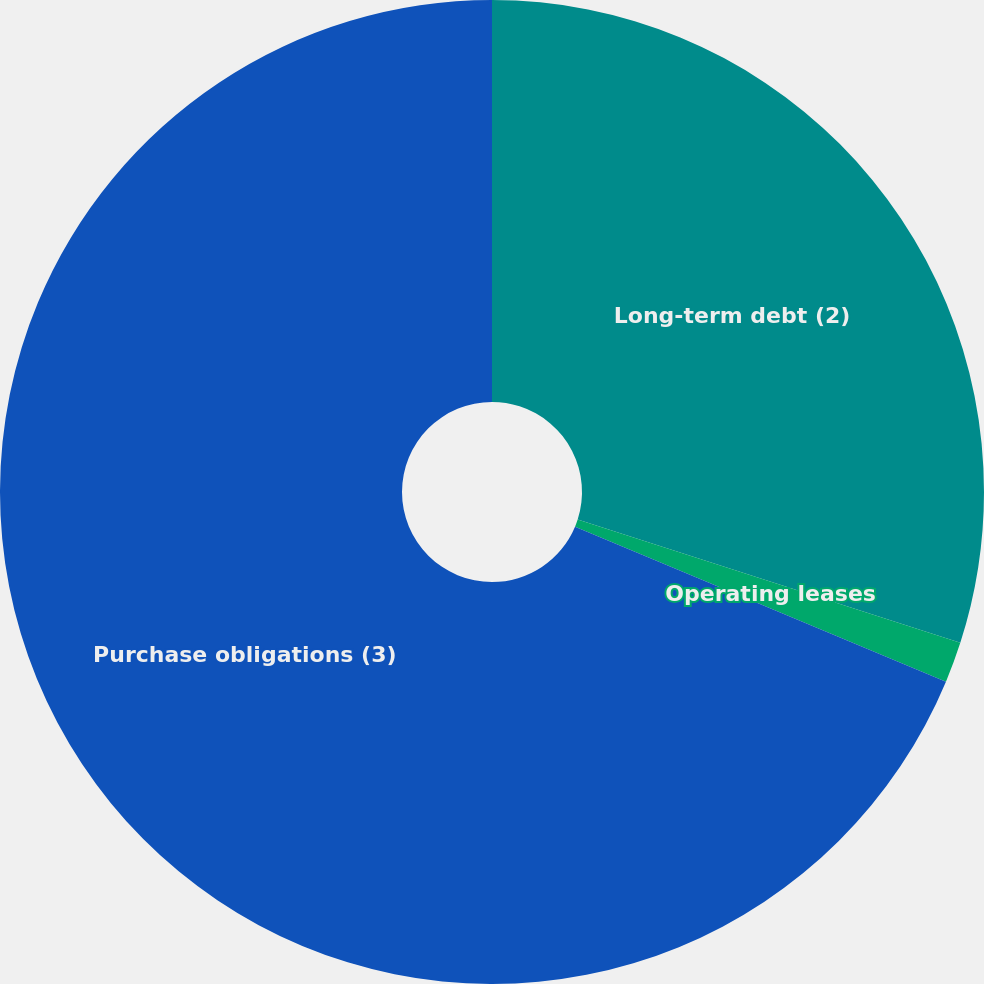<chart> <loc_0><loc_0><loc_500><loc_500><pie_chart><fcel>Long-term debt (2)<fcel>Operating leases<fcel>Purchase obligations (3)<nl><fcel>29.96%<fcel>1.34%<fcel>68.7%<nl></chart> 